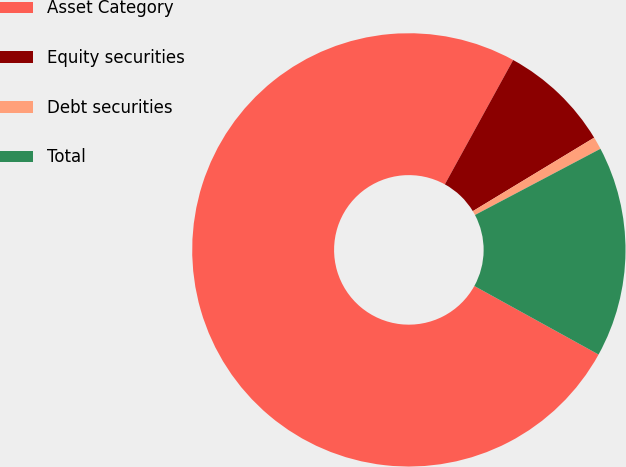Convert chart to OTSL. <chart><loc_0><loc_0><loc_500><loc_500><pie_chart><fcel>Asset Category<fcel>Equity securities<fcel>Debt securities<fcel>Total<nl><fcel>74.98%<fcel>8.34%<fcel>0.94%<fcel>15.75%<nl></chart> 